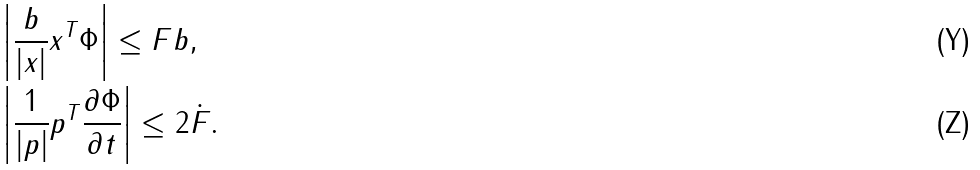Convert formula to latex. <formula><loc_0><loc_0><loc_500><loc_500>& \left | \frac { b } { | x | } x ^ { T } \Phi \right | \leq \| F \| b , \\ & \left | \frac { 1 } { | p | } p ^ { T } \frac { \partial \Phi } { \partial t } \right | \leq 2 \| \dot { F } \| .</formula> 